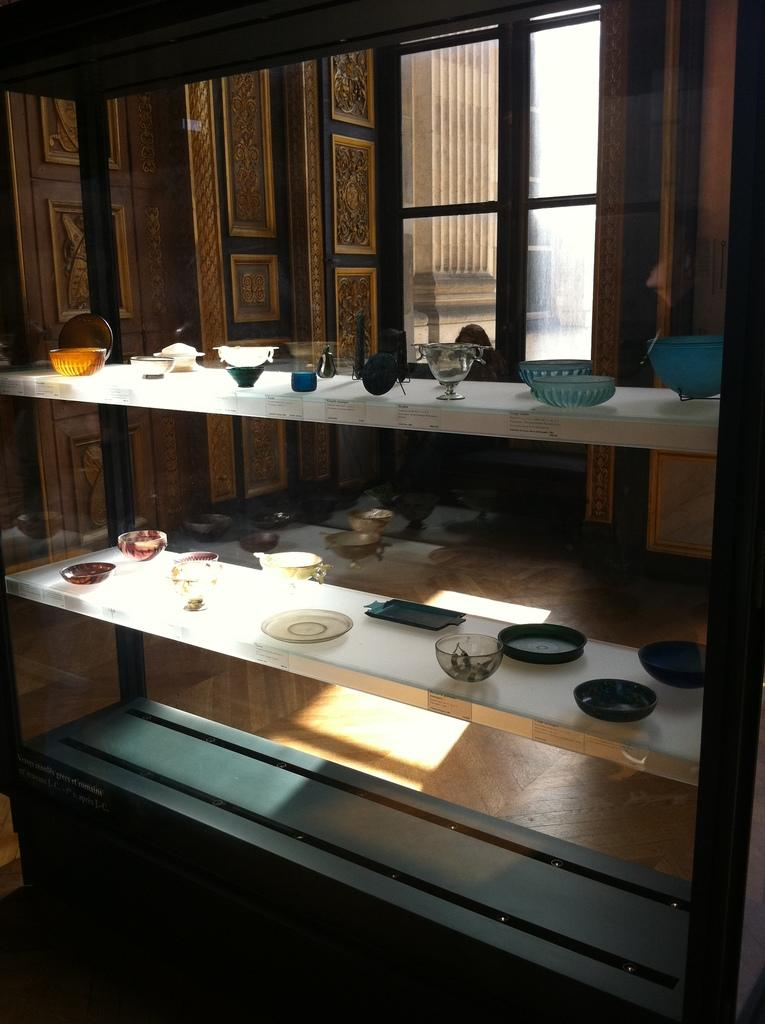What material are the objects in the image made of? The objects in the image are made out of glass. Where are the glass objects located in the image? The glass objects are placed on shelves. What can be seen behind the shelves in the image? There is a window behind the shelves in the image. What type of curtain can be seen hanging from the window in the image? There is no curtain present in the image; only the window is visible behind the shelves. 